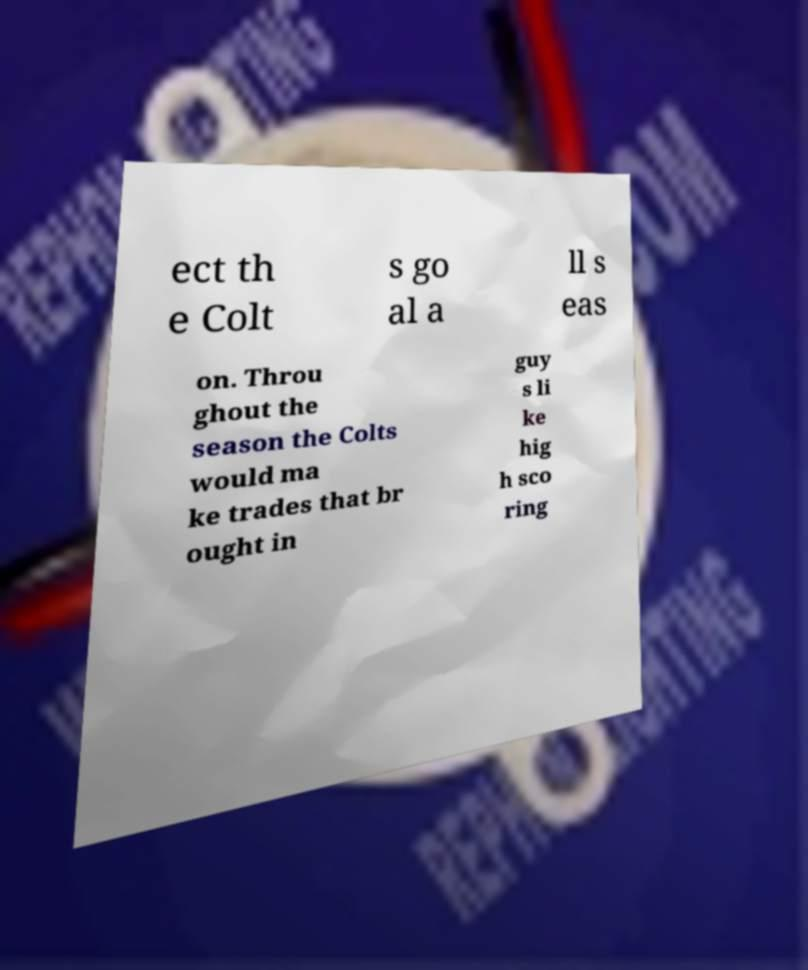Could you extract and type out the text from this image? ect th e Colt s go al a ll s eas on. Throu ghout the season the Colts would ma ke trades that br ought in guy s li ke hig h sco ring 